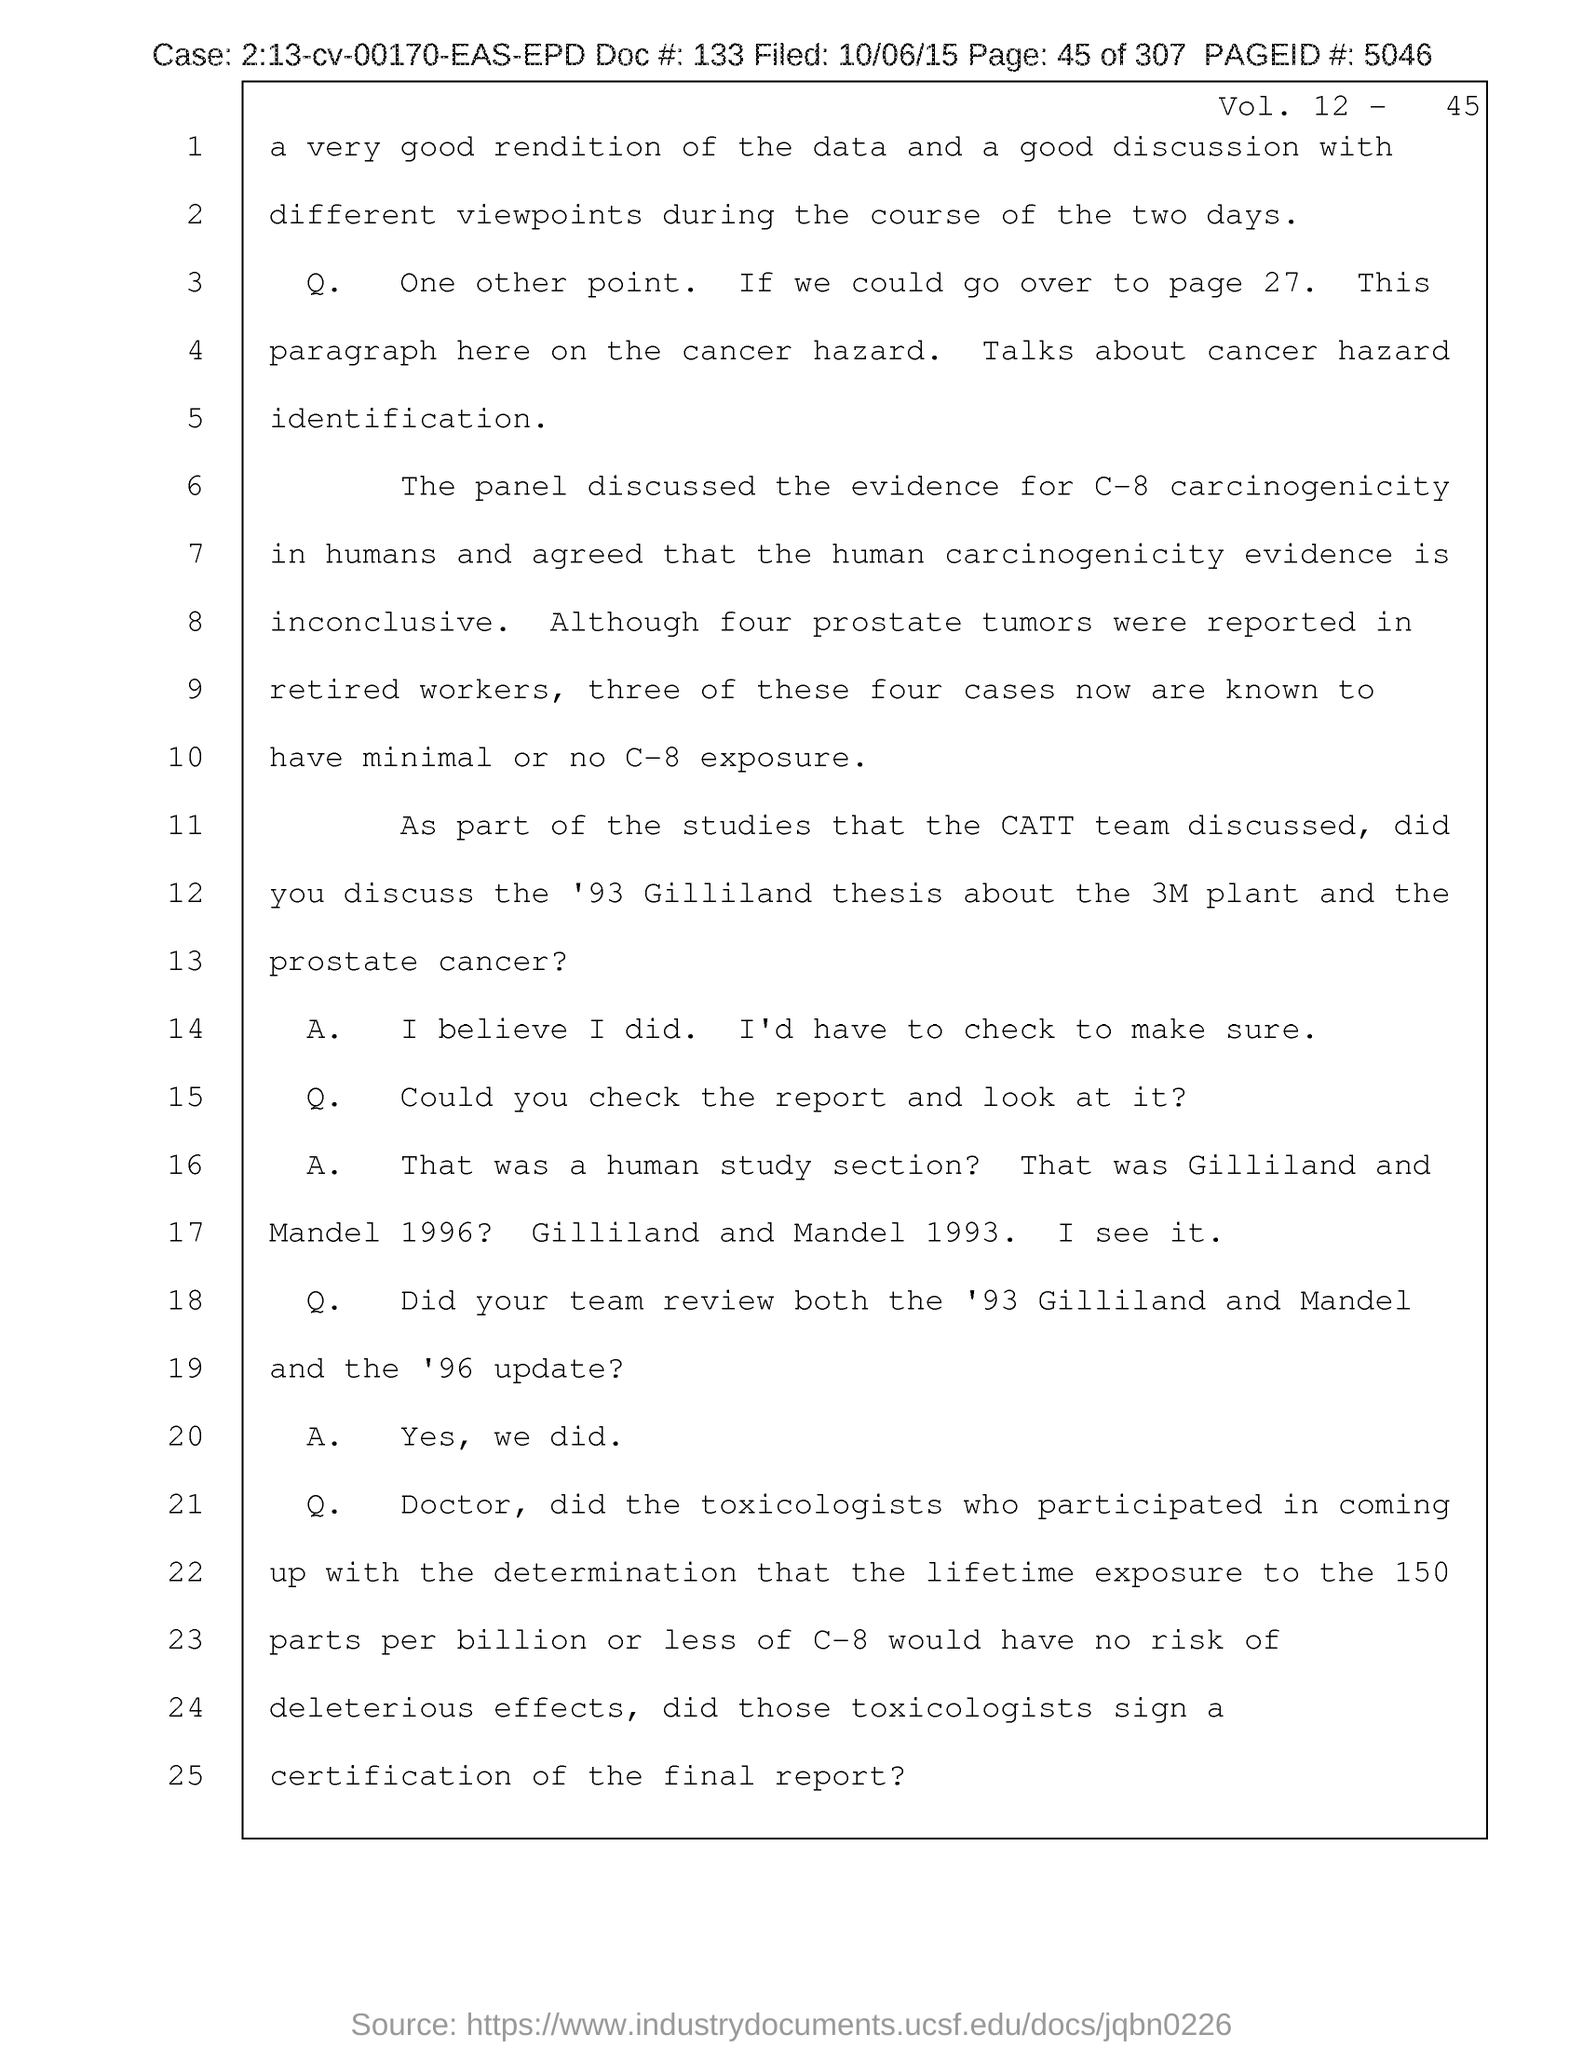What is the case no mentioned in the document?
Provide a short and direct response. 2:13-cv-00170-EAS-EPD. What is the doc # given in the document?
Give a very brief answer. 133. What is the page no mentioned in this document?
Your response must be concise. 45. What is the Page ID # mentioned in the document?
Offer a terse response. 5046. What is the filed date of the document?
Provide a short and direct response. 10/06/15. What is the Vol. no. given in the document?
Keep it short and to the point. 12. 